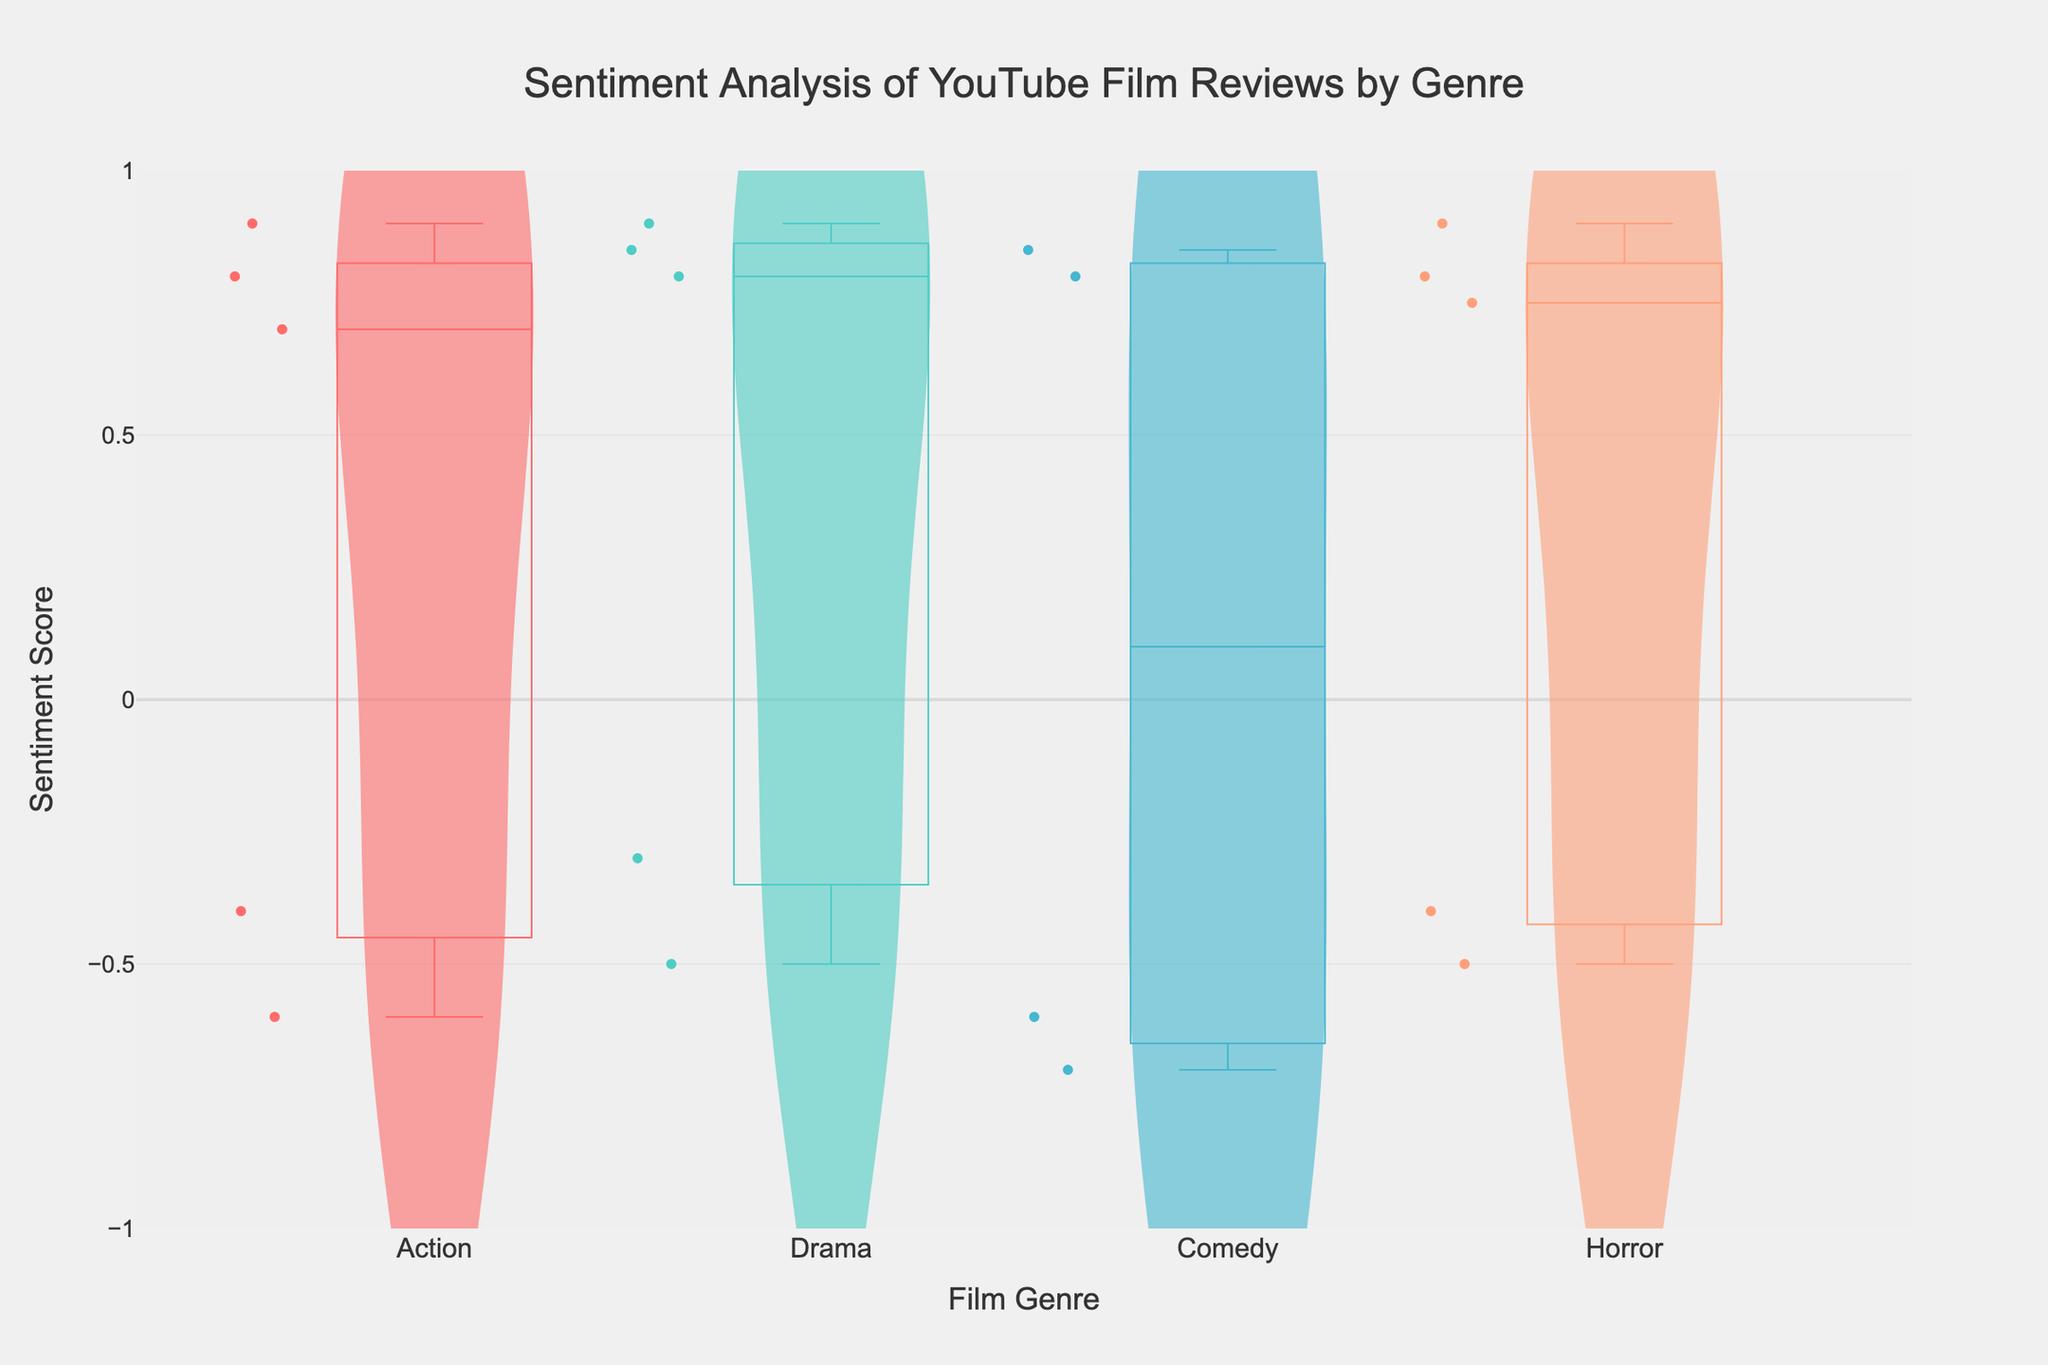What's the overall title of the figure? The title is usually placed at the top of the figure. Here, it reads "Sentiment Analysis of YouTube Film Reviews by Genre".
Answer: Sentiment Analysis of YouTube Film Reviews by Genre What is the range of the sentiment scores on the y-axis? The range of the y-axis is labeled along the side, and it spans from -1 to 1.
Answer: -1 to 1 Which genre has the highest median sentiment score? The median is represented by a line inside the box plot of each violin. The genre with the highest line position is Drama.
Answer: Drama Which genre shows the most variation in sentiment scores? To determine variation, look at the width and spread of the violin plot. The widest and most spread plot is for Action.
Answer: Action Between Comedy and Horror, which has a more positive mean sentiment score? The mean is indicated by the horizontal line in the violin plot. By comparing these lines, we see that Horror has a higher mean sentiment score.
Answer: Horror What does the box plot overlay represent in this figure? The box plot overlay provides a summary of the data distribution, including the quartiles, median, and potential outliers for each genre.
Answer: Data distribution summary Which genre has reviews with sentiment scores closest to zero? The violin plot and box plot for Comedy show most of the values clustered close to the middle line (0).
Answer: Comedy Are there any genres with exclusively negative sentiment scores? We check if any genre has all of its data points below 0. None of the genres have exclusively negative sentiment scores.
Answer: No How do the interquartile ranges (IQRs) of Action and Drama compare? The IQR is the range between the upper and lower quartiles in the box plot. Action's IQR is wider than Drama's.
Answer: Action has a wider IQR Is there any genre with an outlier sentiment below -0.6? Outliers are marked as individual points beyond the whiskers of the box plot. Both Action and Drama have points below -0.6, but for different reasons related to the spread of their data.
Answer: Action and Drama 